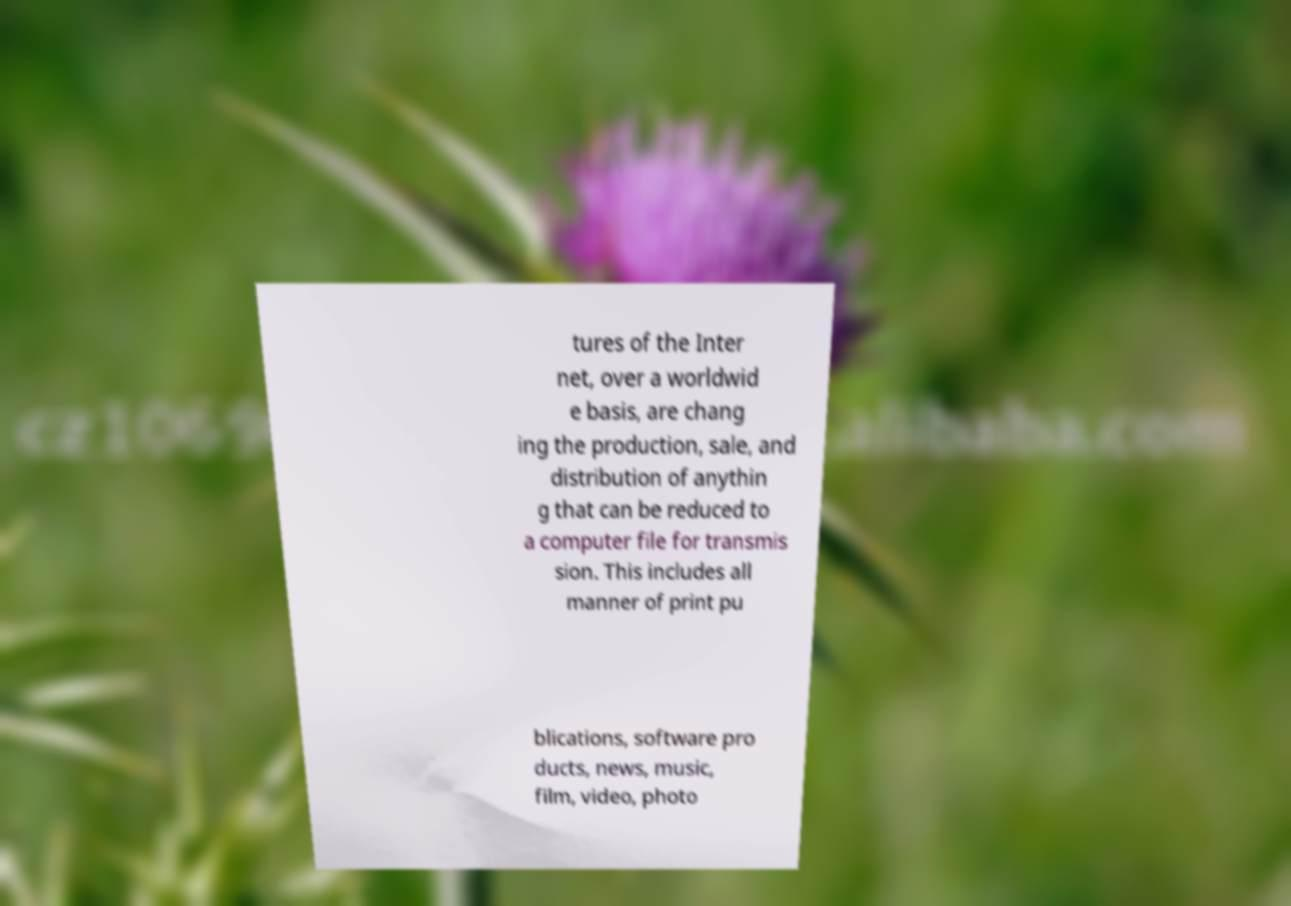There's text embedded in this image that I need extracted. Can you transcribe it verbatim? tures of the Inter net, over a worldwid e basis, are chang ing the production, sale, and distribution of anythin g that can be reduced to a computer file for transmis sion. This includes all manner of print pu blications, software pro ducts, news, music, film, video, photo 